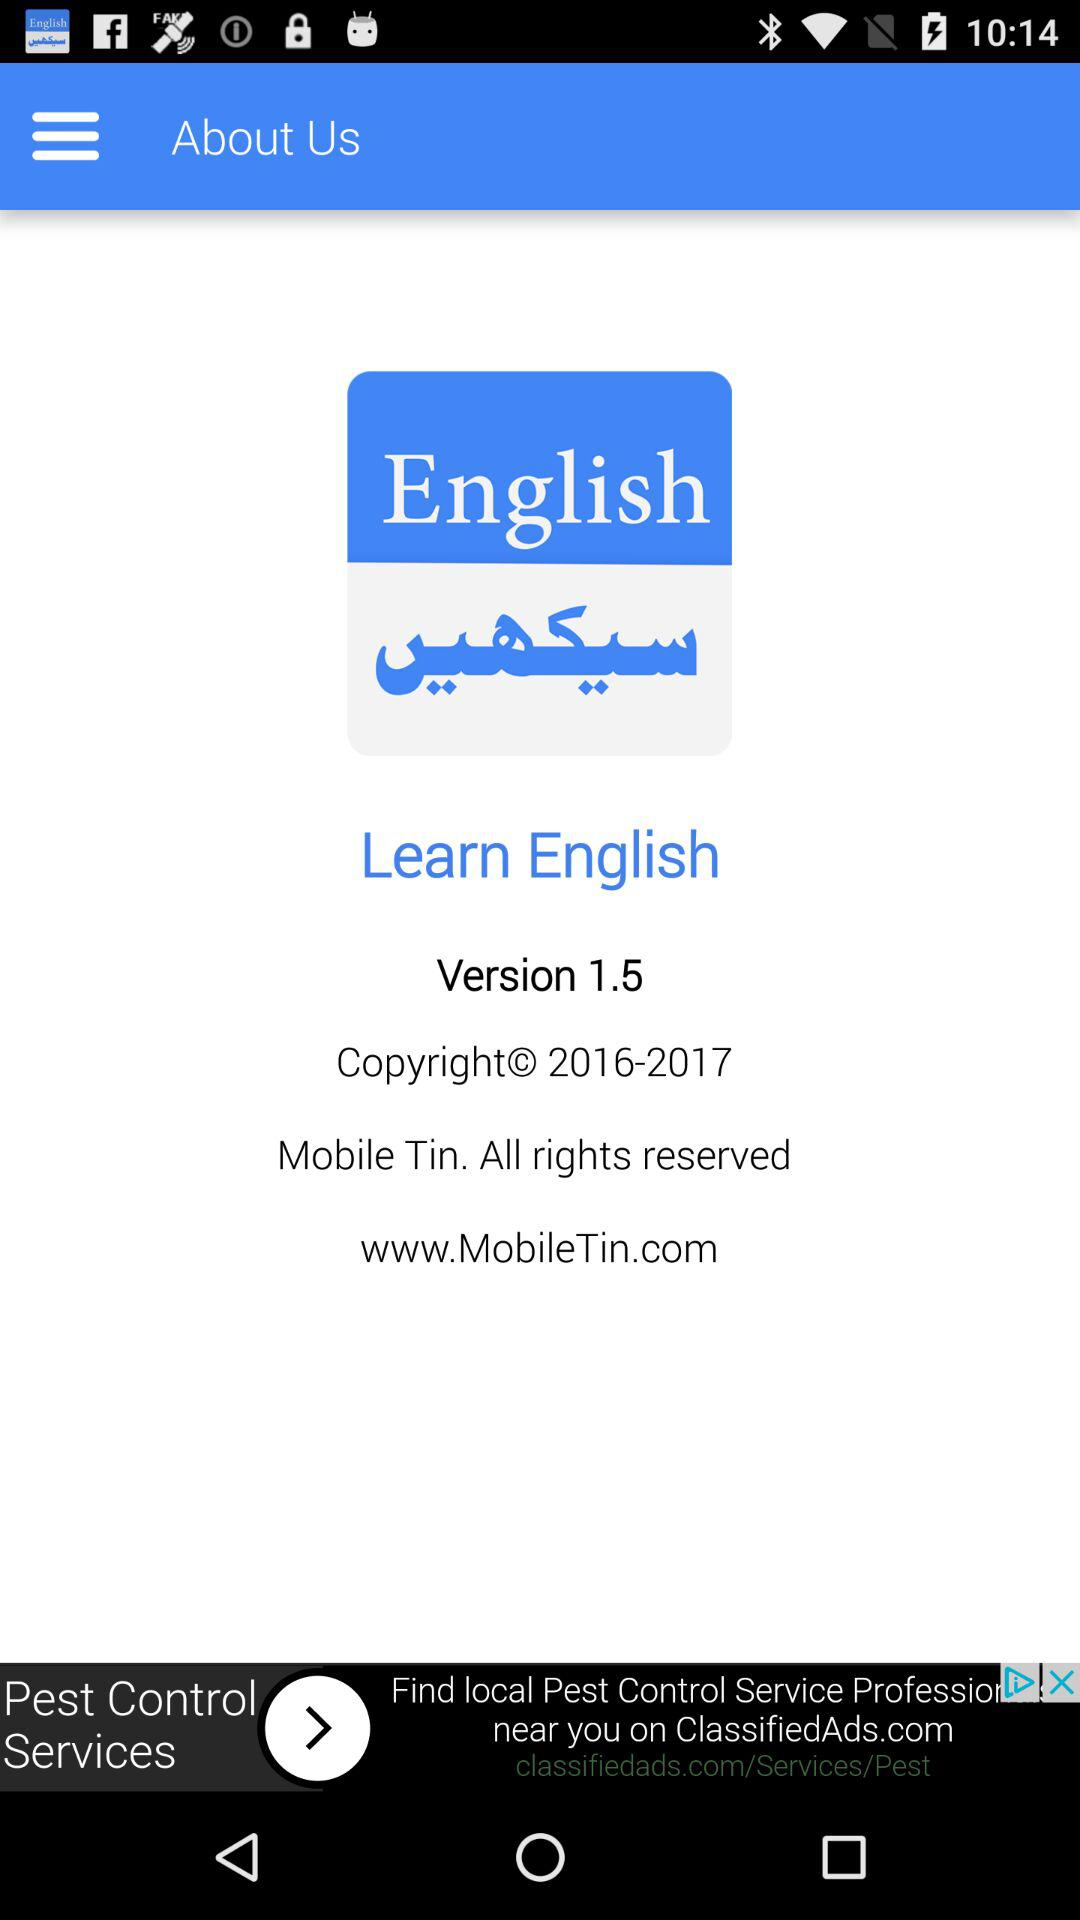What is the version? The version is 1.5. 